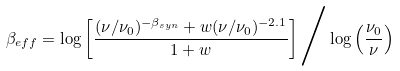<formula> <loc_0><loc_0><loc_500><loc_500>\beta _ { e f f } = \log \left [ \frac { ( \nu / \nu _ { 0 } ) ^ { - \beta _ { s y n } } + w ( \nu / \nu _ { 0 } ) ^ { - 2 . 1 } } { 1 + w } \right ] \Big / \log \left ( \frac { \nu _ { 0 } } { \nu } \right )</formula> 